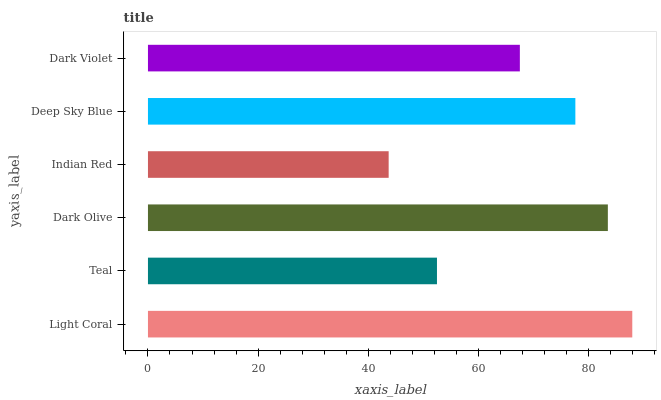Is Indian Red the minimum?
Answer yes or no. Yes. Is Light Coral the maximum?
Answer yes or no. Yes. Is Teal the minimum?
Answer yes or no. No. Is Teal the maximum?
Answer yes or no. No. Is Light Coral greater than Teal?
Answer yes or no. Yes. Is Teal less than Light Coral?
Answer yes or no. Yes. Is Teal greater than Light Coral?
Answer yes or no. No. Is Light Coral less than Teal?
Answer yes or no. No. Is Deep Sky Blue the high median?
Answer yes or no. Yes. Is Dark Violet the low median?
Answer yes or no. Yes. Is Dark Olive the high median?
Answer yes or no. No. Is Light Coral the low median?
Answer yes or no. No. 